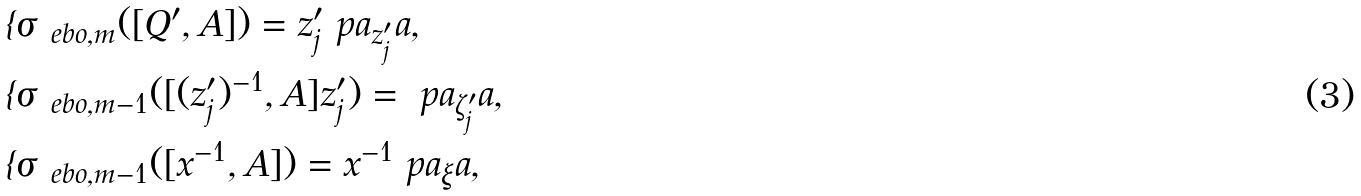Convert formula to latex. <formula><loc_0><loc_0><loc_500><loc_500>& \imath \sigma _ { \ e b o , m } ( [ Q ^ { \prime } , A ] ) = z ^ { \prime } _ { j } \ p a _ { z ^ { \prime } _ { j } } a , \\ & \imath \sigma _ { \ e b o , m - 1 } ( [ ( z ^ { \prime } _ { j } ) ^ { - 1 } , A ] z ^ { \prime } _ { j } ) = \ p a _ { \zeta ^ { \prime } _ { j } } a , \\ & \imath \sigma _ { \ e b o , m - 1 } ( [ x ^ { - 1 } , A ] ) = x ^ { - 1 } \ p a _ { \xi } a ,</formula> 